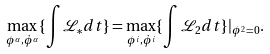<formula> <loc_0><loc_0><loc_500><loc_500>\max _ { \phi ^ { \alpha } , { \dot { \phi } } ^ { \alpha } } \{ \int { \mathcal { L } _ { * } d t } \} = \max _ { \phi ^ { i } , { \dot { \phi } } ^ { i } } \{ \int { \mathcal { L } _ { 2 } d t } \} | _ { { \phi } ^ { 2 } = 0 } .</formula> 